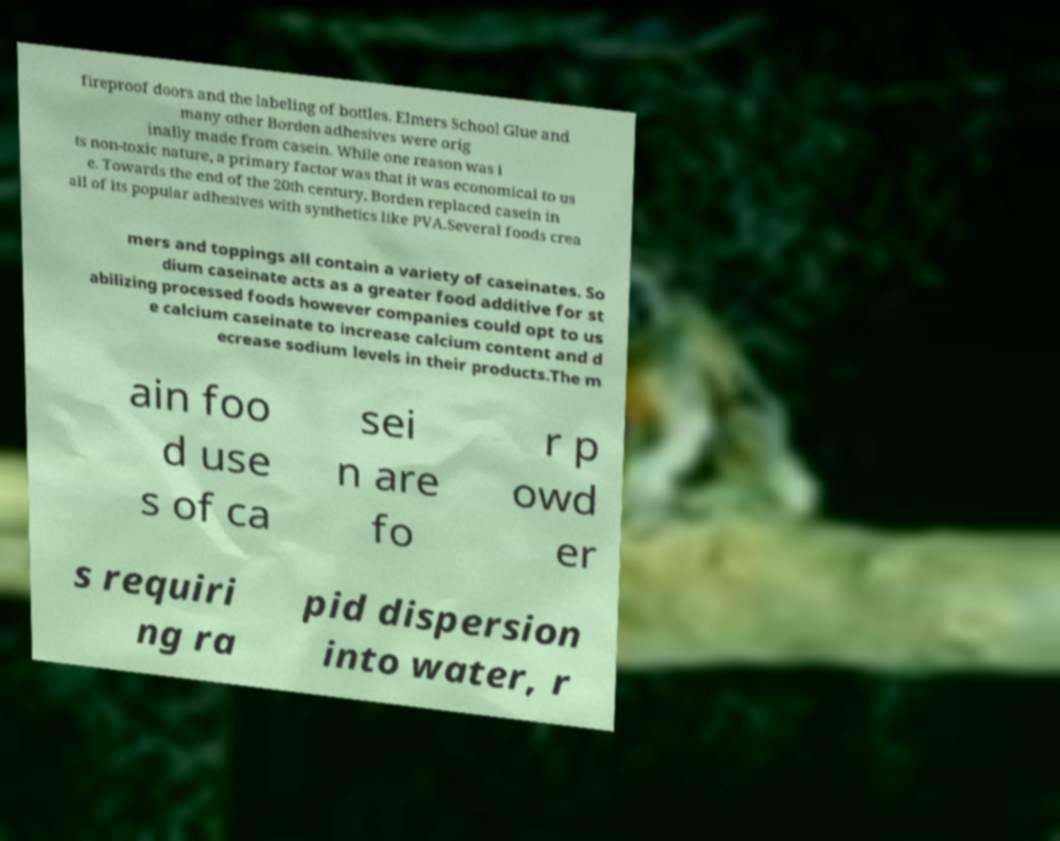What messages or text are displayed in this image? I need them in a readable, typed format. fireproof doors and the labeling of bottles. Elmers School Glue and many other Borden adhesives were orig inally made from casein. While one reason was i ts non-toxic nature, a primary factor was that it was economical to us e. Towards the end of the 20th century, Borden replaced casein in all of its popular adhesives with synthetics like PVA.Several foods crea mers and toppings all contain a variety of caseinates. So dium caseinate acts as a greater food additive for st abilizing processed foods however companies could opt to us e calcium caseinate to increase calcium content and d ecrease sodium levels in their products.The m ain foo d use s of ca sei n are fo r p owd er s requiri ng ra pid dispersion into water, r 